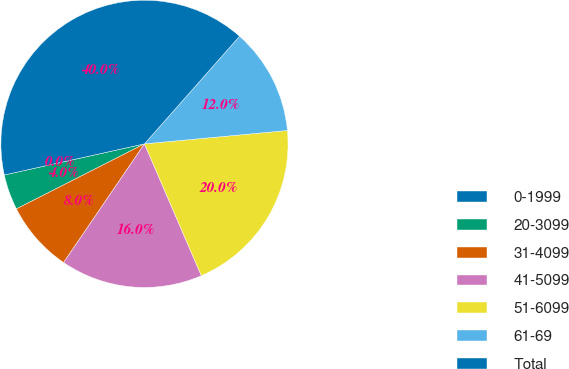<chart> <loc_0><loc_0><loc_500><loc_500><pie_chart><fcel>0-1999<fcel>20-3099<fcel>31-4099<fcel>41-5099<fcel>51-6099<fcel>61-69<fcel>Total<nl><fcel>0.0%<fcel>4.0%<fcel>8.0%<fcel>16.0%<fcel>20.0%<fcel>12.0%<fcel>39.99%<nl></chart> 